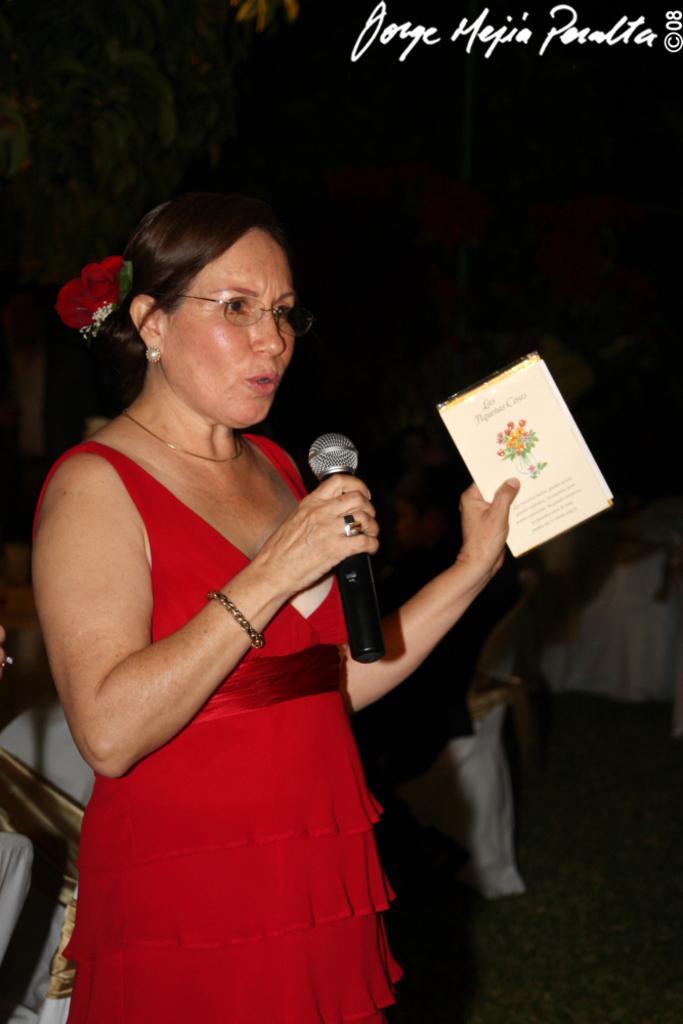In one or two sentences, can you explain what this image depicts? In this image there is a person standing and talking, the person is holding a microphone, the person is holding an object, there is text on the top of the image, there is an object truncated towards the left of the image, there is an object truncated towards the right of the image, there is an object truncated towards the top of the image, the background of the image is dark. 